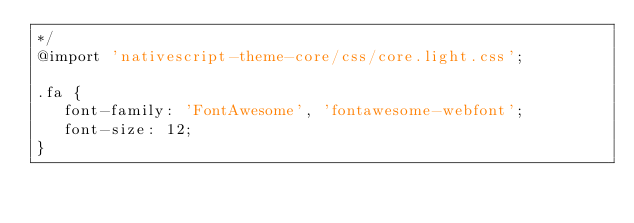<code> <loc_0><loc_0><loc_500><loc_500><_CSS_>*/
@import 'nativescript-theme-core/css/core.light.css';

.fa {
   font-family: 'FontAwesome', 'fontawesome-webfont';
   font-size: 12;
}
</code> 